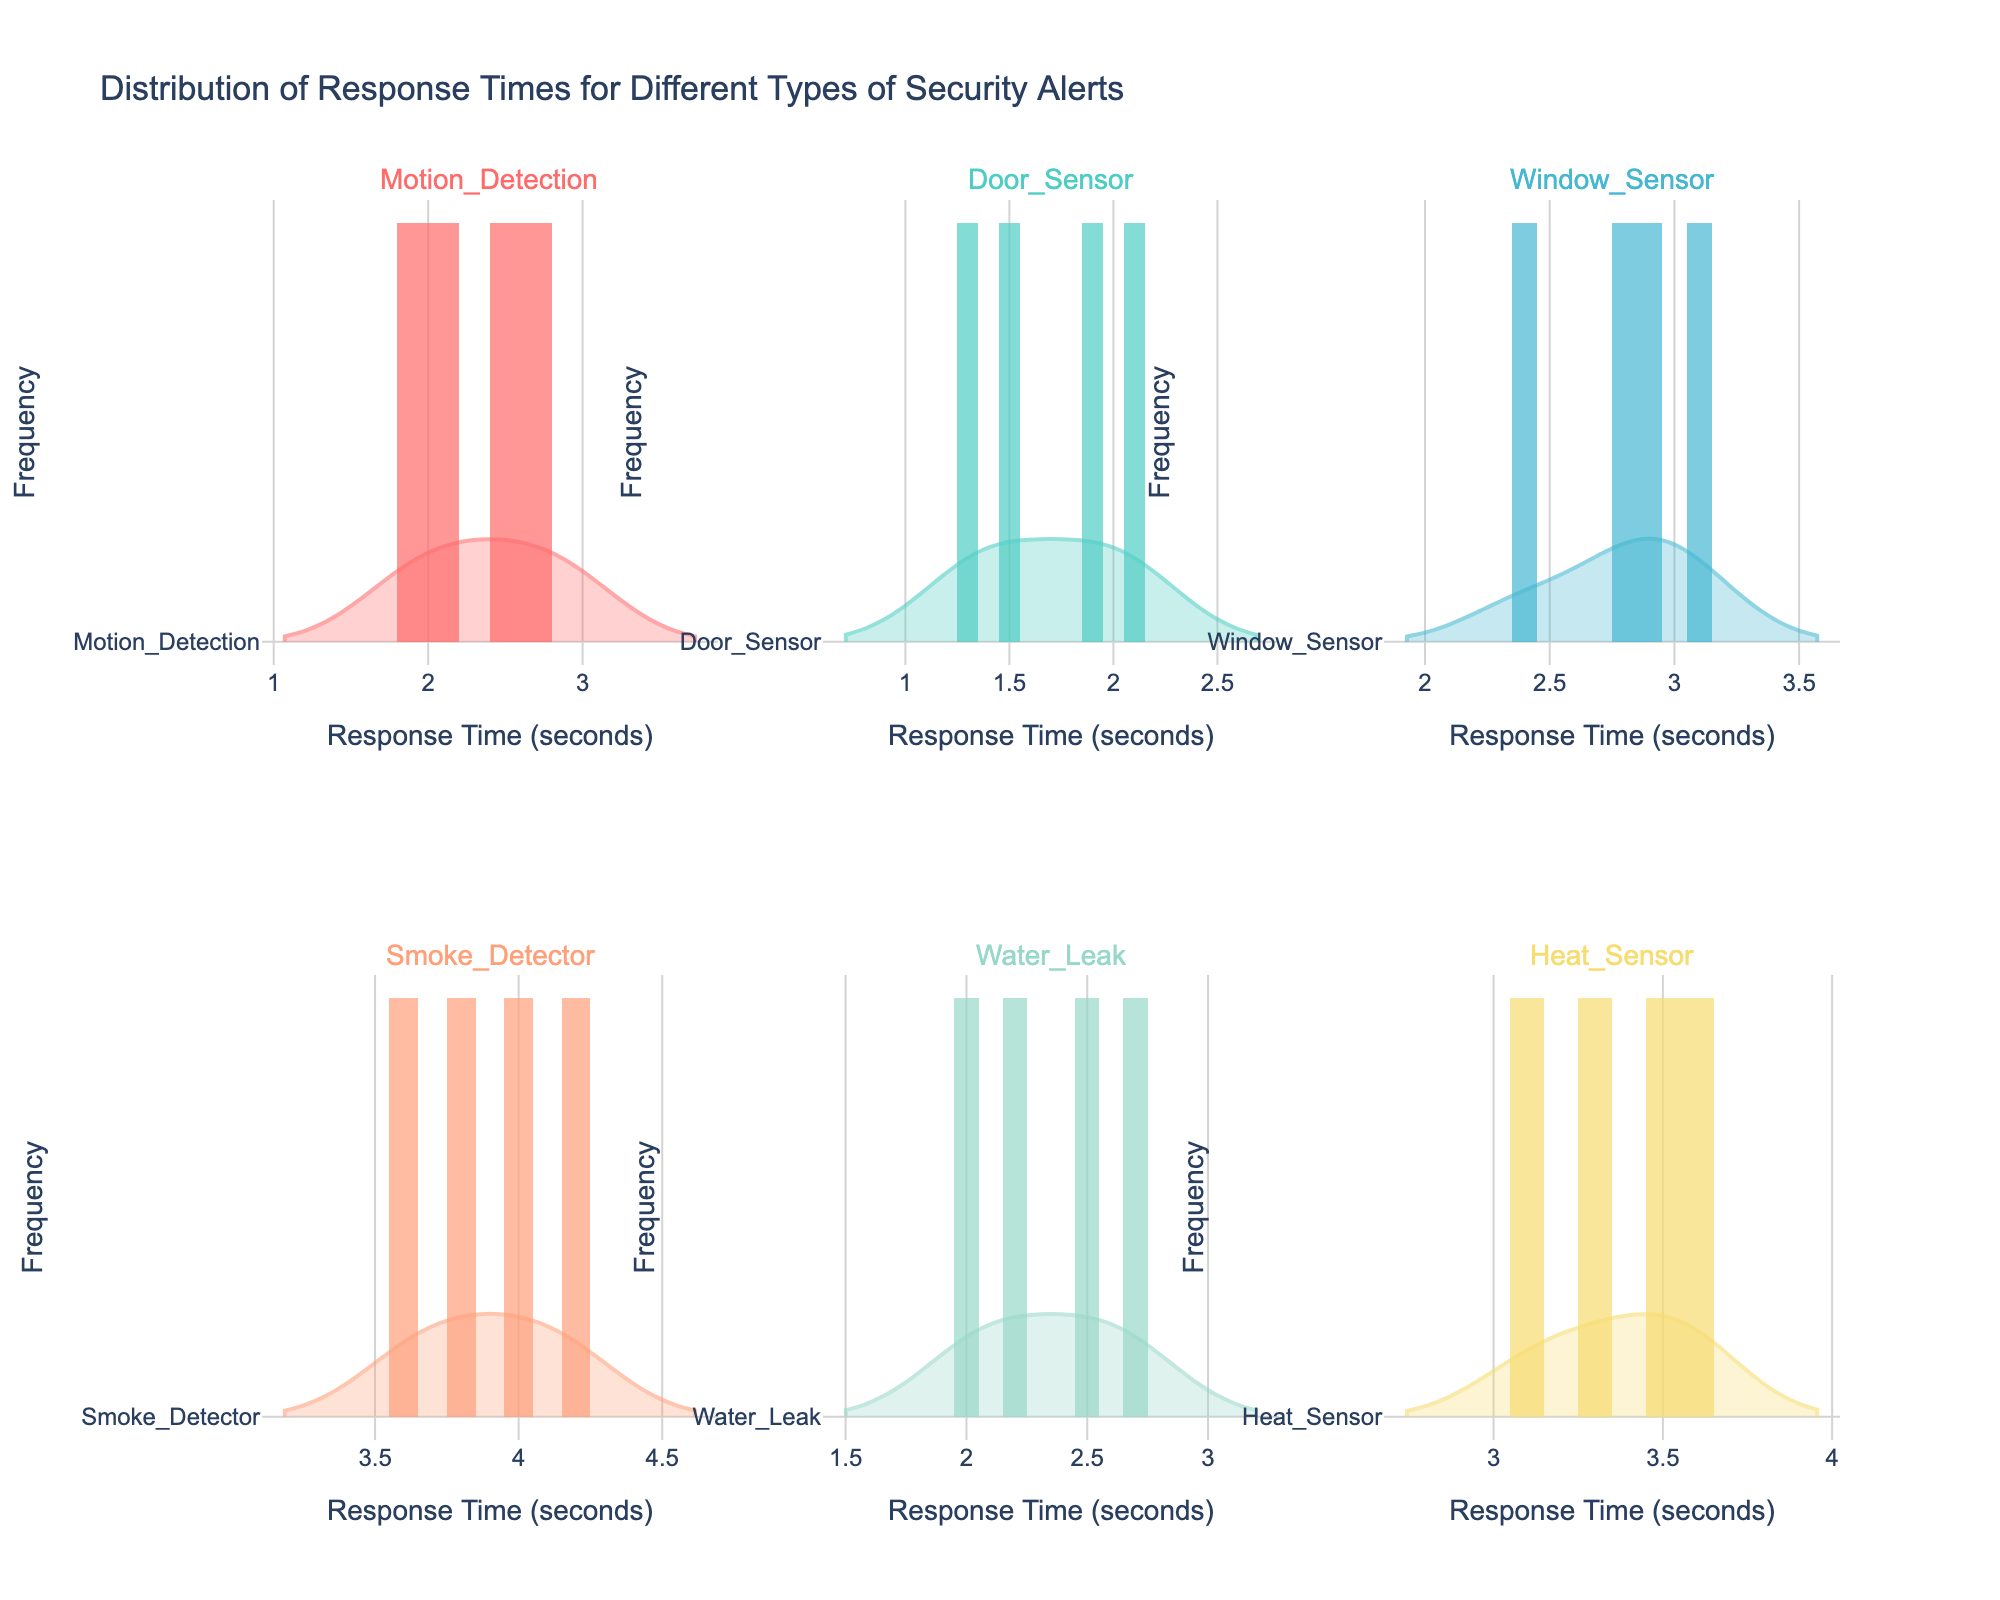What's the title of the figure? The title is positioned at the top center of the figure.
Answer: Distribution of Response Times for Different Types of Security Alerts How many different types of security alerts are represented in the figure? Each subplot title represents a different type of security alert, counting all unique subplots gives us the answer.
Answer: 5 What is the axis label for the x-axis? The label for the x-axis is positioned below the horizontal axis within all subplots.
Answer: Response Time (seconds) Which alert type shows the highest average response time? By examining the position of the peak for each alert type's histogram and violin plot, the Smoke_Detector response times are generally centered around the highest values.
Answer: Smoke_Detector Which alert type has the most narrow range of response times? Assessing the width of each histogram and the spread of each violin plot indicates that Door_Sensor has the most concentrated data range around 1.5 to 2.1 seconds.
Answer: Door_Sensor How does the response time for Heat_Sensor alerts compare to that of Water_Leak alerts? By comparing the histograms and violin plots, Heat_Sensor has response times mostly between 3.1 to 3.6 seconds while Water_Leak ranges primarily from 2.0 to 2.7 seconds, indicating that Heat_Sensor takes longer on average.
Answer: Heat_Sensor takes longer Which alert type shows the highest response time recorded in the dataset? The highest point in the violin plot showcases the extreme values, indicating that Smoke_Detector has responses around 4.2 seconds, the highest in the dataset.
Answer: Smoke_Detector What is the frequency of ResponseTime values around 2 seconds for Motion_Detection alerts? The height of the histogram bars around the 2-second mark in the Motion_Detection subplot indicates this is a frequent value.
Answer: High frequency Is there any alert type whose response times are not overlapping with another alert type? Comparing ranges and overlaps in the violin plots, Smoke_Detector averages the highest values with minimal overlap with other alert types.
Answer: Smoke_Detector Which alert type tends to have response times below 2 seconds? Observing the left side of the histograms, Door_Sensor has many values below 2 seconds.
Answer: Door_Sensor 